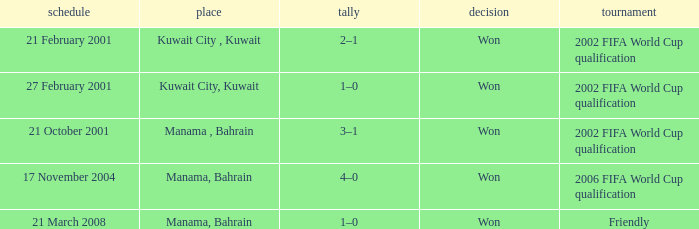What was the final score of the Friendly Competition in Manama, Bahrain? 1–0. 